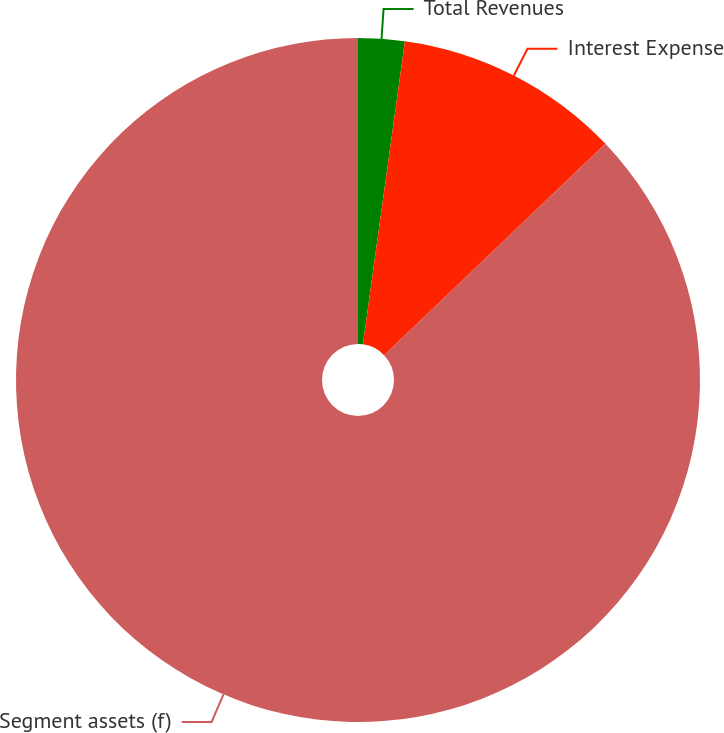Convert chart. <chart><loc_0><loc_0><loc_500><loc_500><pie_chart><fcel>Total Revenues<fcel>Interest Expense<fcel>Segment assets (f)<nl><fcel>2.19%<fcel>10.68%<fcel>87.13%<nl></chart> 